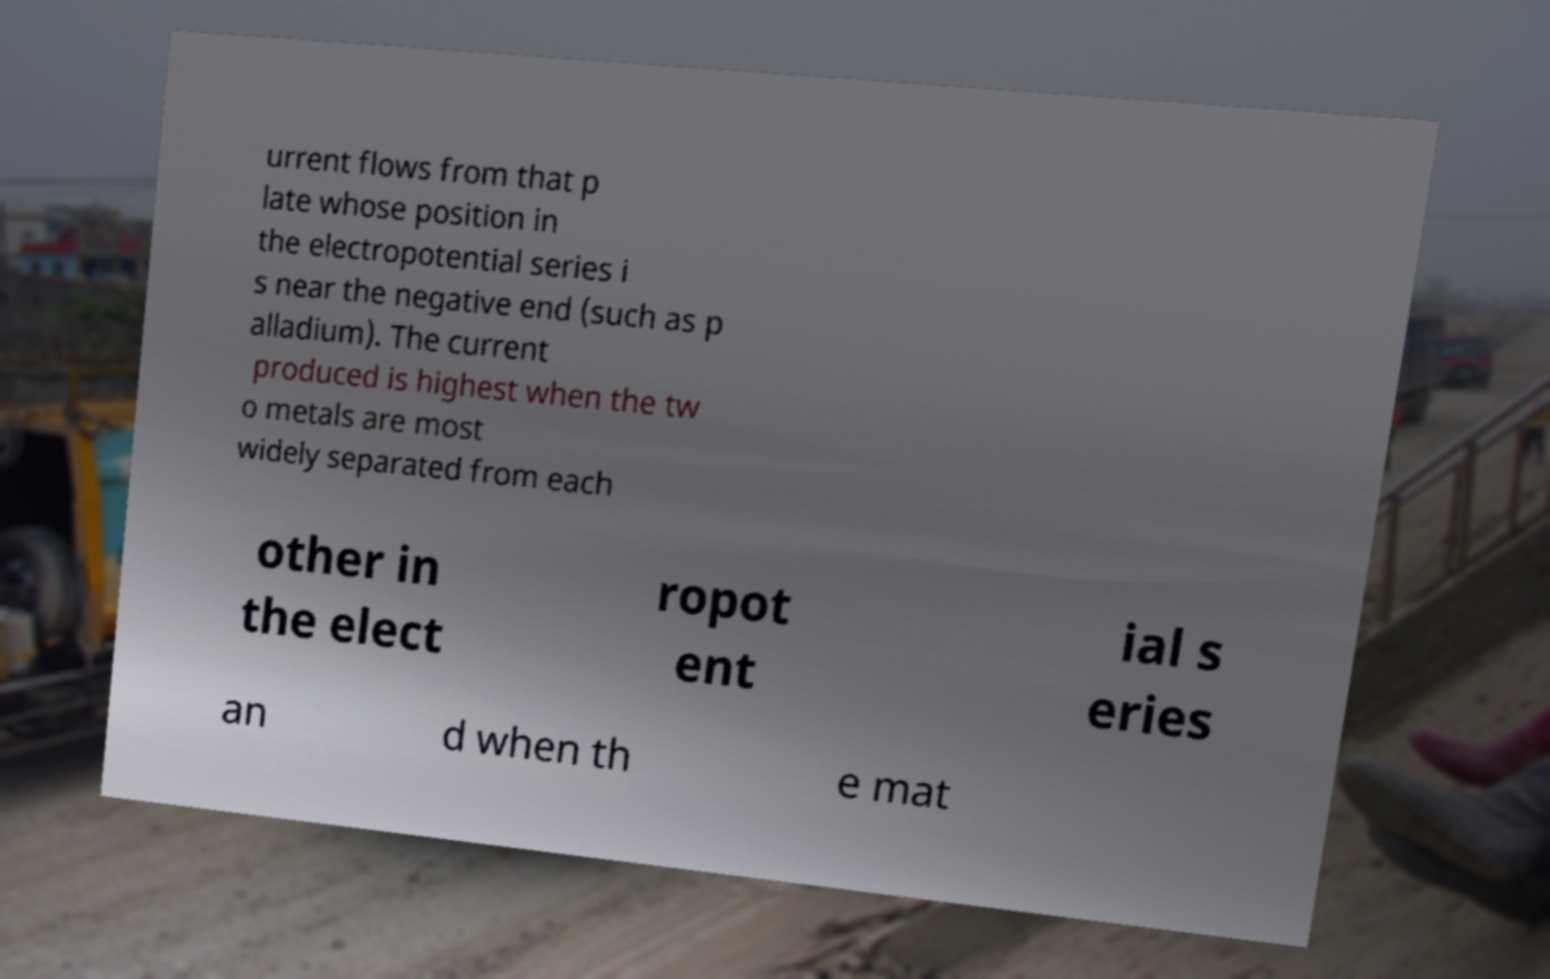Could you assist in decoding the text presented in this image and type it out clearly? urrent flows from that p late whose position in the electropotential series i s near the negative end (such as p alladium). The current produced is highest when the tw o metals are most widely separated from each other in the elect ropot ent ial s eries an d when th e mat 